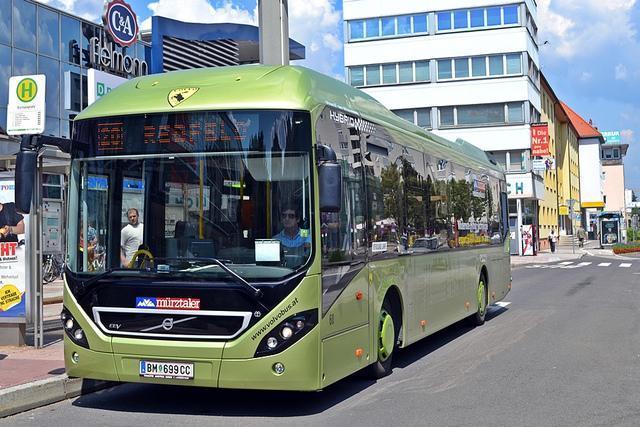How many horses are in the picture?
Give a very brief answer. 0. 